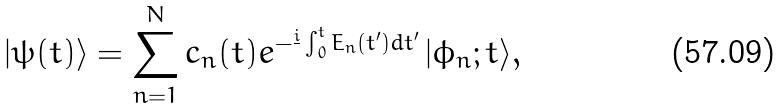Convert formula to latex. <formula><loc_0><loc_0><loc_500><loc_500>| \psi ( t ) \rangle = \sum _ { n = 1 } ^ { N } c _ { n } ( t ) e ^ { - \frac { i } { } \int _ { 0 } ^ { t } E _ { n } ( t ^ { \prime } ) d t ^ { \prime } } \, | \phi _ { n } ; t \rangle ,</formula> 